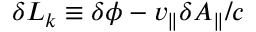<formula> <loc_0><loc_0><loc_500><loc_500>\delta L _ { k } \equiv \delta \phi - v _ { \| } \delta A _ { \| } / c</formula> 